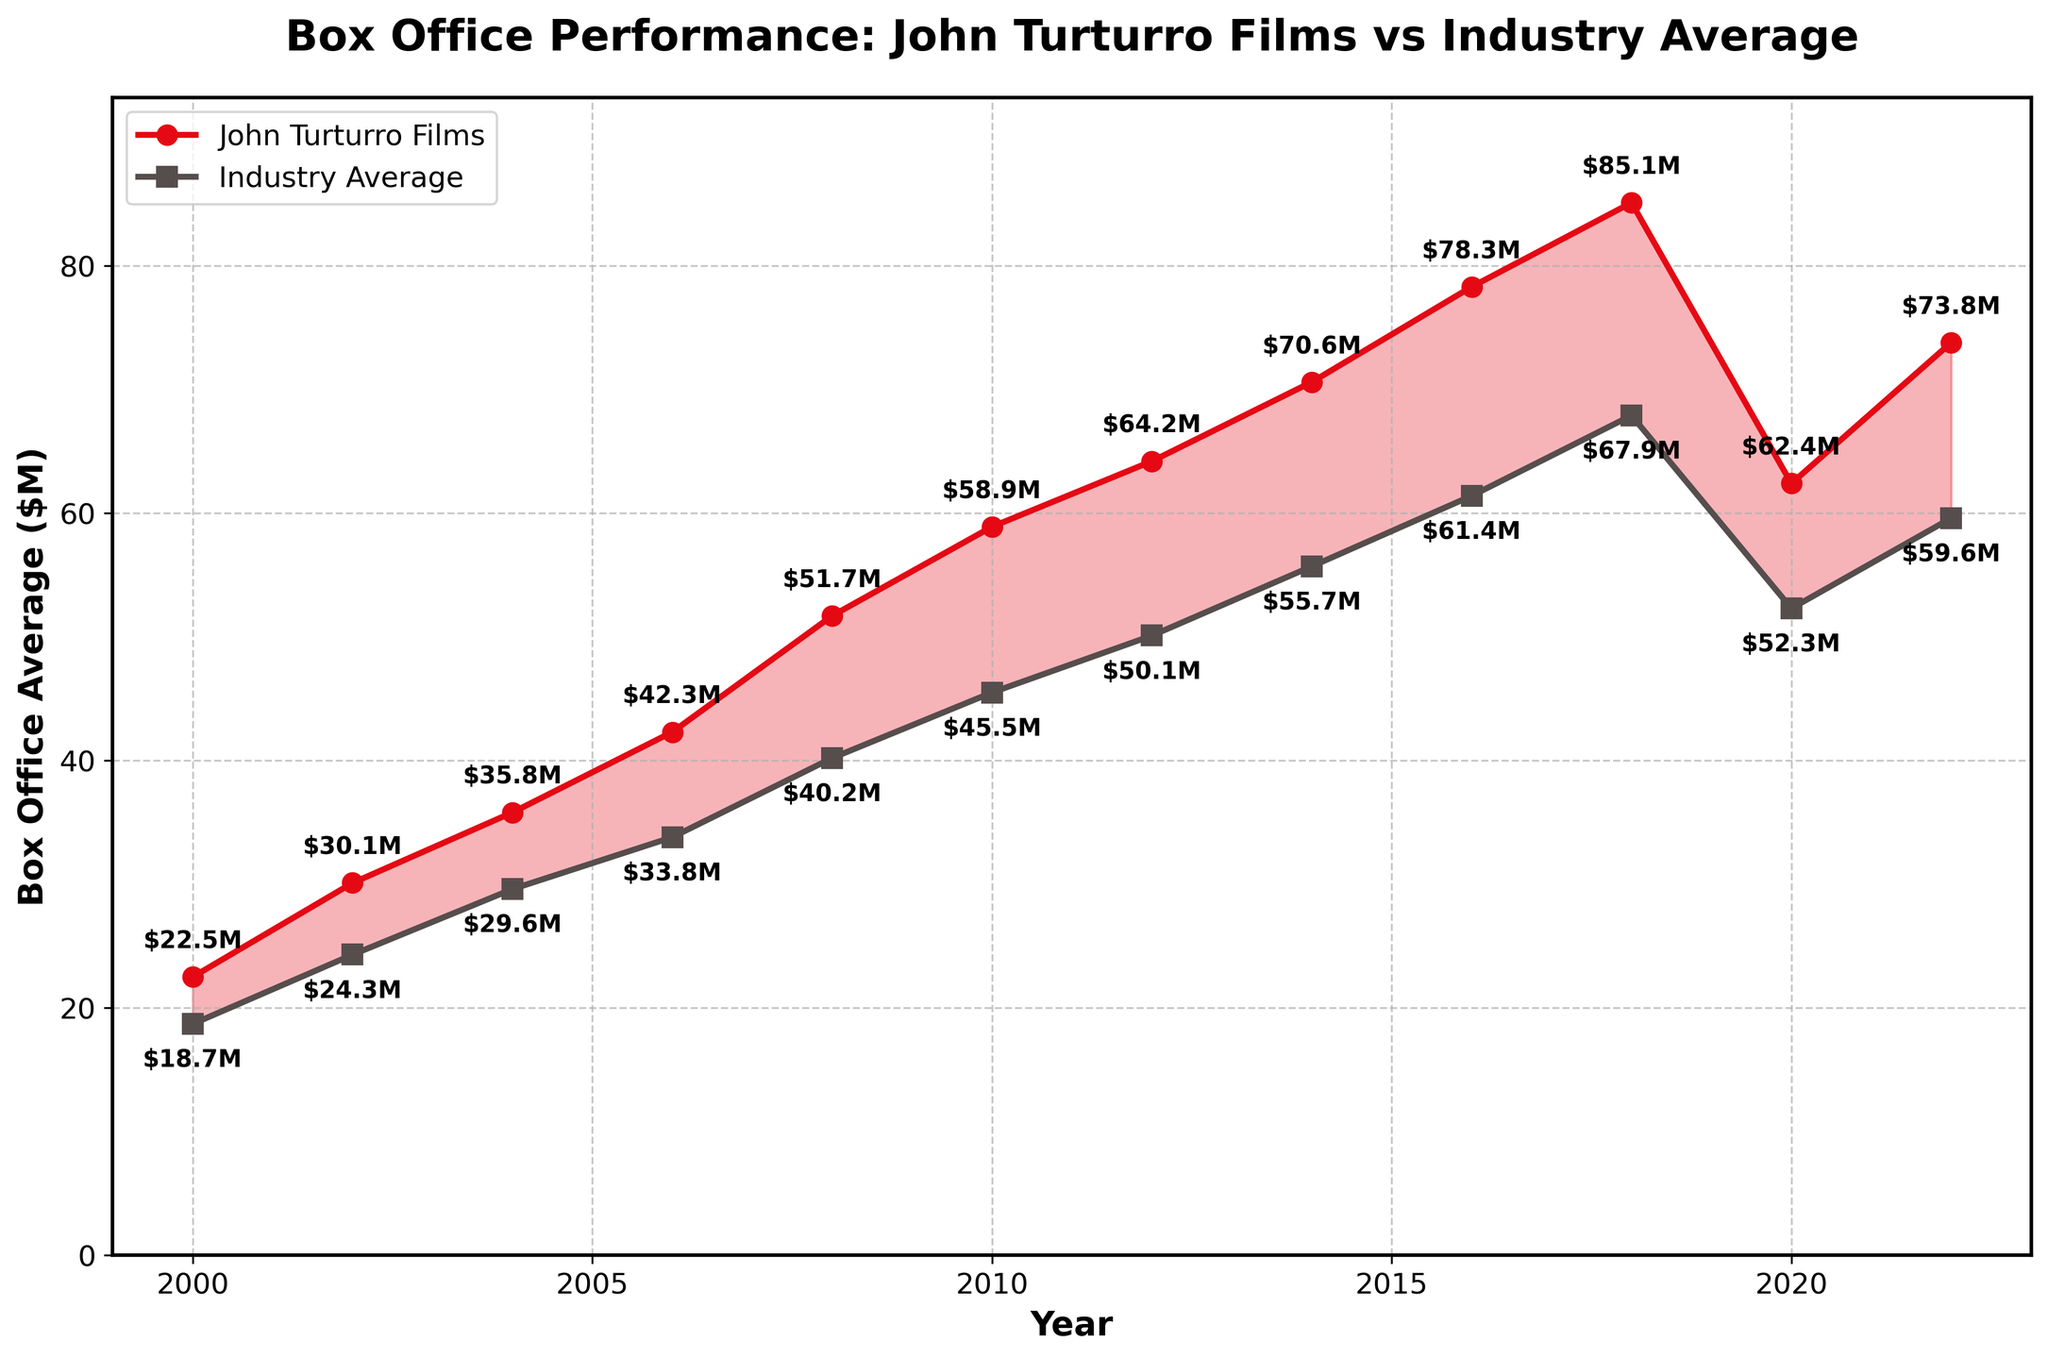What's the overall trend in the box office performance of John Turturro's films from 2000 to 2022? The line representing John Turturro's films shows a general upward trend with a peak around 2018, followed by a dip in 2020, and then a rise again in 2022.
Answer: Upward trend with minor fluctuations Which year had the highest average box office earnings for John Turturro's films? By examining the line chart, the highest point on the red line is in 2018, signifying the peak average earnings.
Answer: 2018 During which years did John Turturro's films outperform the industry average? The red line is above the gray line in the years 2000, 2002, 2004, 2006, 2008, 2010, 2012, 2014, 2016, 2018, 2022.
Answer: 2000, 2002, 2004, 2006, 2008, 2010, 2012, 2014, 2016, 2018, 2022 By how much did John Turturro's films exceed the industry average in 2018? The average for Turturro's films in 2018 was $85.1M, while the industry average was $67.9M. The difference is $85.1M - $67.9M = $17.2M.
Answer: $17.2M What is the percentage increase in the average box office performance of John Turturro's films from 2000 to 2018? The average in 2000 was $22.5M and in 2018 it was $85.1M. The increase is $85.1M - $22.5M = $62.6M. The percentage increase is ($62.6M / $22.5M) * 100 ≈ 278%.
Answer: 278% In which year was the difference between the box office performance of John Turturro's films and the industry average the smallest? By comparing the gaps between the two lines, the smallest difference is in 2020 where John Turturro’s films averaged $62.4M and the industry average was $52.3M, a difference of $10.1M.
Answer: 2020 What is the average box office performance of the industry over the years shown? To calculate the average, sum all the industry average values and divide by the number of years. Total is (18.7 + 24.3 + 29.6 + 33.8 + 40.2 + 45.5 + 50.1 + 55.7 + 61.4 + 67.9 + 52.3 + 59.6) = 539.1. There are 12 years, so the average is 539.1 / 12 ≈ 44.9.
Answer: 44.9M How did the average box office performance of Turturro's films change between 2020 and 2022? In 2020, the average was $62.4M, and in 2022 it was $73.8M. The change is $73.8M - $62.4M = $11.4M, showing an increase.
Answer: Increased by $11.4M Which year shows the largest gap between Turturro's films and the industry average? The largest vertical gap between the two lines is visible in 2016, where the average for Turturro's films was $78.3M and that of the industry was $61.4M, giving a difference of $16.9M.
Answer: 2016 